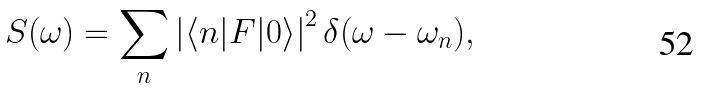<formula> <loc_0><loc_0><loc_500><loc_500>S ( \omega ) = \sum _ { n } \left | \langle n | F | 0 \rangle \right | ^ { 2 } \delta ( \omega - \omega _ { n } ) ,</formula> 